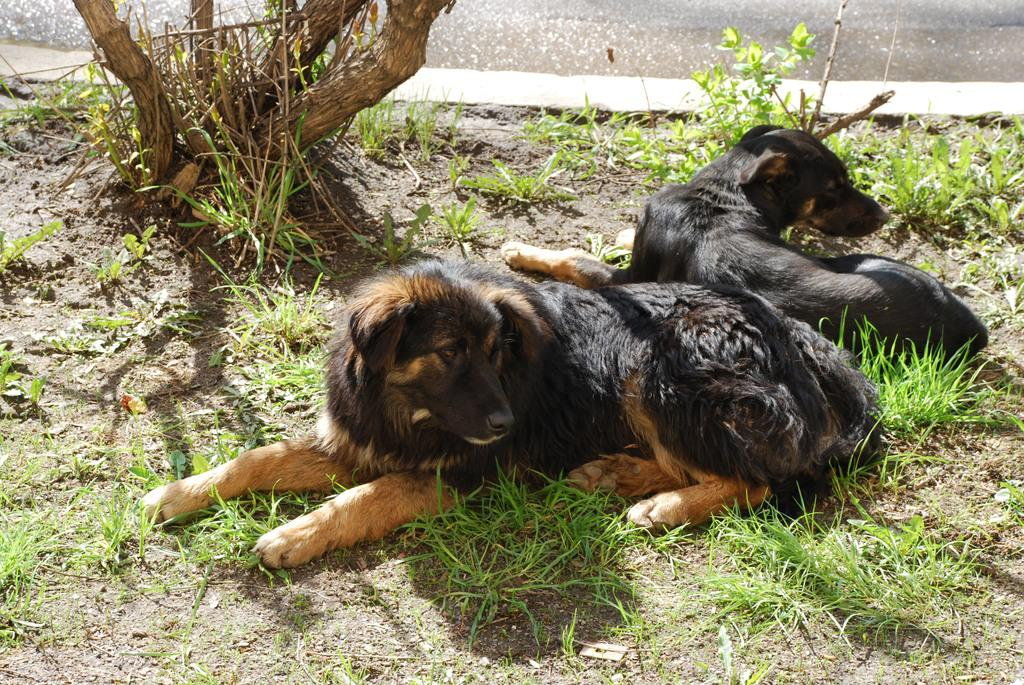How many dogs are present in the image? There are two dogs on the floor in the image. What else can be seen in the image besides the dogs? There are plants and grass in the image. What is visible in the background of the image? There is a water body and a tree in the background of the image. What type of engine can be seen powering the hole in the image? There is no engine or hole present in the image. 